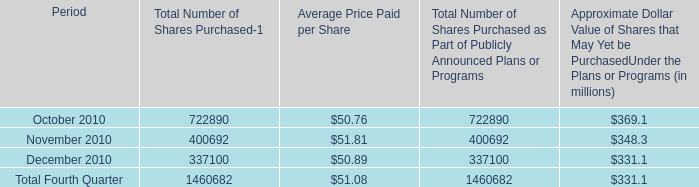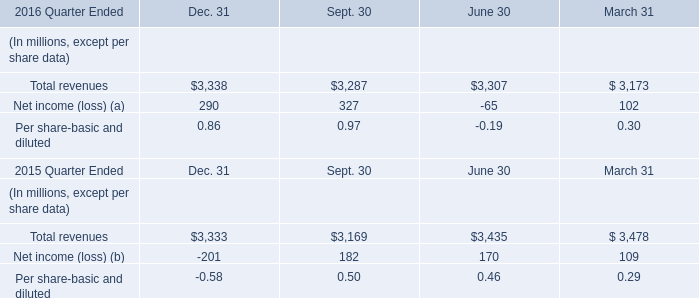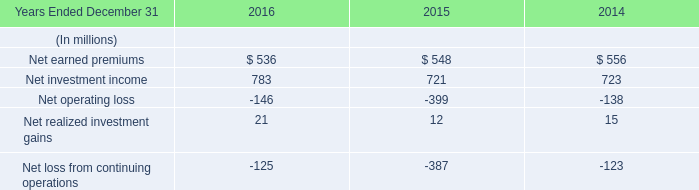what was the weighted average price per share of the shares 30.9 repurchased as of february 11 , 2011 
Computations: (1.2 / 30.9)
Answer: 0.03883. 